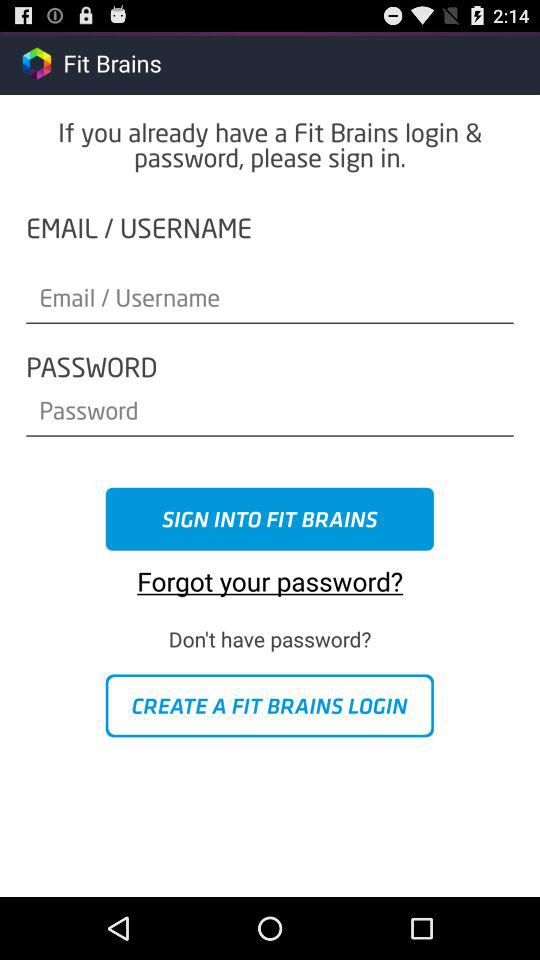What is the name of the application? The name of the application is "Fit Brains". 